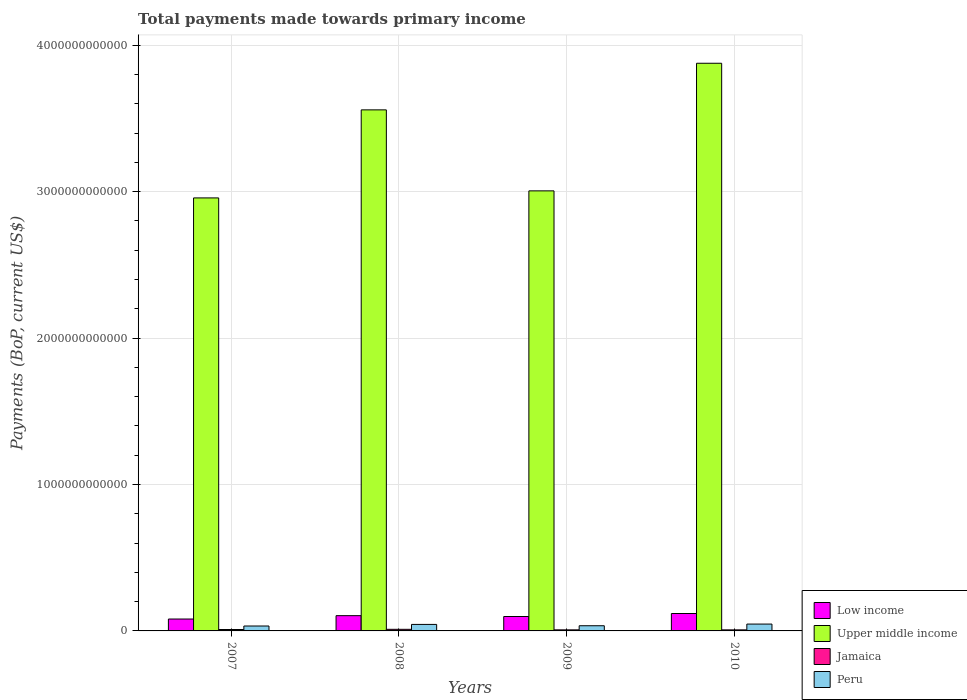How many different coloured bars are there?
Provide a succinct answer. 4. How many groups of bars are there?
Provide a succinct answer. 4. Are the number of bars on each tick of the X-axis equal?
Provide a short and direct response. Yes. How many bars are there on the 3rd tick from the left?
Provide a succinct answer. 4. What is the total payments made towards primary income in Jamaica in 2008?
Your answer should be very brief. 1.10e+1. Across all years, what is the maximum total payments made towards primary income in Low income?
Ensure brevity in your answer.  1.19e+11. Across all years, what is the minimum total payments made towards primary income in Upper middle income?
Keep it short and to the point. 2.96e+12. What is the total total payments made towards primary income in Upper middle income in the graph?
Your answer should be very brief. 1.34e+13. What is the difference between the total payments made towards primary income in Upper middle income in 2007 and that in 2009?
Give a very brief answer. -4.81e+1. What is the difference between the total payments made towards primary income in Upper middle income in 2008 and the total payments made towards primary income in Peru in 2010?
Make the answer very short. 3.51e+12. What is the average total payments made towards primary income in Upper middle income per year?
Provide a succinct answer. 3.35e+12. In the year 2007, what is the difference between the total payments made towards primary income in Peru and total payments made towards primary income in Jamaica?
Give a very brief answer. 2.39e+1. What is the ratio of the total payments made towards primary income in Peru in 2007 to that in 2010?
Ensure brevity in your answer.  0.72. Is the total payments made towards primary income in Jamaica in 2007 less than that in 2009?
Offer a terse response. No. What is the difference between the highest and the second highest total payments made towards primary income in Jamaica?
Provide a short and direct response. 1.30e+09. What is the difference between the highest and the lowest total payments made towards primary income in Peru?
Ensure brevity in your answer.  1.32e+1. In how many years, is the total payments made towards primary income in Upper middle income greater than the average total payments made towards primary income in Upper middle income taken over all years?
Your response must be concise. 2. Is it the case that in every year, the sum of the total payments made towards primary income in Low income and total payments made towards primary income in Jamaica is greater than the sum of total payments made towards primary income in Peru and total payments made towards primary income in Upper middle income?
Your answer should be compact. Yes. Is it the case that in every year, the sum of the total payments made towards primary income in Upper middle income and total payments made towards primary income in Peru is greater than the total payments made towards primary income in Low income?
Ensure brevity in your answer.  Yes. How many bars are there?
Offer a very short reply. 16. Are all the bars in the graph horizontal?
Give a very brief answer. No. How many years are there in the graph?
Your answer should be compact. 4. What is the difference between two consecutive major ticks on the Y-axis?
Your answer should be compact. 1.00e+12. Are the values on the major ticks of Y-axis written in scientific E-notation?
Keep it short and to the point. No. Does the graph contain any zero values?
Give a very brief answer. No. Does the graph contain grids?
Keep it short and to the point. Yes. How many legend labels are there?
Your answer should be compact. 4. How are the legend labels stacked?
Give a very brief answer. Vertical. What is the title of the graph?
Offer a very short reply. Total payments made towards primary income. What is the label or title of the Y-axis?
Offer a very short reply. Payments (BoP, current US$). What is the Payments (BoP, current US$) in Low income in 2007?
Give a very brief answer. 8.12e+1. What is the Payments (BoP, current US$) of Upper middle income in 2007?
Your answer should be compact. 2.96e+12. What is the Payments (BoP, current US$) in Jamaica in 2007?
Keep it short and to the point. 9.67e+09. What is the Payments (BoP, current US$) of Peru in 2007?
Provide a short and direct response. 3.36e+1. What is the Payments (BoP, current US$) of Low income in 2008?
Your answer should be very brief. 1.04e+11. What is the Payments (BoP, current US$) in Upper middle income in 2008?
Offer a very short reply. 3.56e+12. What is the Payments (BoP, current US$) in Jamaica in 2008?
Your answer should be compact. 1.10e+1. What is the Payments (BoP, current US$) of Peru in 2008?
Your answer should be very brief. 4.44e+1. What is the Payments (BoP, current US$) of Low income in 2009?
Provide a succinct answer. 9.84e+1. What is the Payments (BoP, current US$) in Upper middle income in 2009?
Give a very brief answer. 3.01e+12. What is the Payments (BoP, current US$) in Jamaica in 2009?
Offer a very short reply. 7.26e+09. What is the Payments (BoP, current US$) in Peru in 2009?
Offer a terse response. 3.54e+1. What is the Payments (BoP, current US$) of Low income in 2010?
Ensure brevity in your answer.  1.19e+11. What is the Payments (BoP, current US$) of Upper middle income in 2010?
Offer a terse response. 3.88e+12. What is the Payments (BoP, current US$) of Jamaica in 2010?
Provide a short and direct response. 7.19e+09. What is the Payments (BoP, current US$) of Peru in 2010?
Keep it short and to the point. 4.68e+1. Across all years, what is the maximum Payments (BoP, current US$) in Low income?
Make the answer very short. 1.19e+11. Across all years, what is the maximum Payments (BoP, current US$) of Upper middle income?
Give a very brief answer. 3.88e+12. Across all years, what is the maximum Payments (BoP, current US$) in Jamaica?
Your response must be concise. 1.10e+1. Across all years, what is the maximum Payments (BoP, current US$) in Peru?
Make the answer very short. 4.68e+1. Across all years, what is the minimum Payments (BoP, current US$) of Low income?
Offer a terse response. 8.12e+1. Across all years, what is the minimum Payments (BoP, current US$) in Upper middle income?
Your answer should be very brief. 2.96e+12. Across all years, what is the minimum Payments (BoP, current US$) in Jamaica?
Keep it short and to the point. 7.19e+09. Across all years, what is the minimum Payments (BoP, current US$) in Peru?
Your answer should be very brief. 3.36e+1. What is the total Payments (BoP, current US$) of Low income in the graph?
Provide a short and direct response. 4.03e+11. What is the total Payments (BoP, current US$) of Upper middle income in the graph?
Your answer should be very brief. 1.34e+13. What is the total Payments (BoP, current US$) in Jamaica in the graph?
Your answer should be very brief. 3.51e+1. What is the total Payments (BoP, current US$) of Peru in the graph?
Offer a very short reply. 1.60e+11. What is the difference between the Payments (BoP, current US$) of Low income in 2007 and that in 2008?
Keep it short and to the point. -2.30e+1. What is the difference between the Payments (BoP, current US$) in Upper middle income in 2007 and that in 2008?
Ensure brevity in your answer.  -6.01e+11. What is the difference between the Payments (BoP, current US$) in Jamaica in 2007 and that in 2008?
Make the answer very short. -1.30e+09. What is the difference between the Payments (BoP, current US$) in Peru in 2007 and that in 2008?
Ensure brevity in your answer.  -1.08e+1. What is the difference between the Payments (BoP, current US$) of Low income in 2007 and that in 2009?
Provide a succinct answer. -1.71e+1. What is the difference between the Payments (BoP, current US$) in Upper middle income in 2007 and that in 2009?
Make the answer very short. -4.81e+1. What is the difference between the Payments (BoP, current US$) in Jamaica in 2007 and that in 2009?
Your response must be concise. 2.41e+09. What is the difference between the Payments (BoP, current US$) of Peru in 2007 and that in 2009?
Your answer should be compact. -1.85e+09. What is the difference between the Payments (BoP, current US$) in Low income in 2007 and that in 2010?
Keep it short and to the point. -3.77e+1. What is the difference between the Payments (BoP, current US$) of Upper middle income in 2007 and that in 2010?
Give a very brief answer. -9.20e+11. What is the difference between the Payments (BoP, current US$) in Jamaica in 2007 and that in 2010?
Keep it short and to the point. 2.48e+09. What is the difference between the Payments (BoP, current US$) in Peru in 2007 and that in 2010?
Ensure brevity in your answer.  -1.32e+1. What is the difference between the Payments (BoP, current US$) in Low income in 2008 and that in 2009?
Keep it short and to the point. 5.85e+09. What is the difference between the Payments (BoP, current US$) of Upper middle income in 2008 and that in 2009?
Offer a terse response. 5.53e+11. What is the difference between the Payments (BoP, current US$) of Jamaica in 2008 and that in 2009?
Make the answer very short. 3.71e+09. What is the difference between the Payments (BoP, current US$) in Peru in 2008 and that in 2009?
Provide a succinct answer. 8.99e+09. What is the difference between the Payments (BoP, current US$) in Low income in 2008 and that in 2010?
Provide a succinct answer. -1.47e+1. What is the difference between the Payments (BoP, current US$) of Upper middle income in 2008 and that in 2010?
Provide a short and direct response. -3.18e+11. What is the difference between the Payments (BoP, current US$) of Jamaica in 2008 and that in 2010?
Provide a short and direct response. 3.78e+09. What is the difference between the Payments (BoP, current US$) in Peru in 2008 and that in 2010?
Give a very brief answer. -2.39e+09. What is the difference between the Payments (BoP, current US$) in Low income in 2009 and that in 2010?
Provide a short and direct response. -2.05e+1. What is the difference between the Payments (BoP, current US$) of Upper middle income in 2009 and that in 2010?
Make the answer very short. -8.71e+11. What is the difference between the Payments (BoP, current US$) of Jamaica in 2009 and that in 2010?
Give a very brief answer. 6.76e+07. What is the difference between the Payments (BoP, current US$) of Peru in 2009 and that in 2010?
Give a very brief answer. -1.14e+1. What is the difference between the Payments (BoP, current US$) of Low income in 2007 and the Payments (BoP, current US$) of Upper middle income in 2008?
Provide a short and direct response. -3.48e+12. What is the difference between the Payments (BoP, current US$) in Low income in 2007 and the Payments (BoP, current US$) in Jamaica in 2008?
Ensure brevity in your answer.  7.03e+1. What is the difference between the Payments (BoP, current US$) of Low income in 2007 and the Payments (BoP, current US$) of Peru in 2008?
Provide a succinct answer. 3.68e+1. What is the difference between the Payments (BoP, current US$) of Upper middle income in 2007 and the Payments (BoP, current US$) of Jamaica in 2008?
Offer a terse response. 2.95e+12. What is the difference between the Payments (BoP, current US$) of Upper middle income in 2007 and the Payments (BoP, current US$) of Peru in 2008?
Your answer should be compact. 2.91e+12. What is the difference between the Payments (BoP, current US$) of Jamaica in 2007 and the Payments (BoP, current US$) of Peru in 2008?
Your answer should be compact. -3.47e+1. What is the difference between the Payments (BoP, current US$) in Low income in 2007 and the Payments (BoP, current US$) in Upper middle income in 2009?
Your answer should be compact. -2.92e+12. What is the difference between the Payments (BoP, current US$) in Low income in 2007 and the Payments (BoP, current US$) in Jamaica in 2009?
Your answer should be compact. 7.40e+1. What is the difference between the Payments (BoP, current US$) of Low income in 2007 and the Payments (BoP, current US$) of Peru in 2009?
Provide a succinct answer. 4.58e+1. What is the difference between the Payments (BoP, current US$) in Upper middle income in 2007 and the Payments (BoP, current US$) in Jamaica in 2009?
Make the answer very short. 2.95e+12. What is the difference between the Payments (BoP, current US$) of Upper middle income in 2007 and the Payments (BoP, current US$) of Peru in 2009?
Offer a very short reply. 2.92e+12. What is the difference between the Payments (BoP, current US$) of Jamaica in 2007 and the Payments (BoP, current US$) of Peru in 2009?
Offer a terse response. -2.57e+1. What is the difference between the Payments (BoP, current US$) of Low income in 2007 and the Payments (BoP, current US$) of Upper middle income in 2010?
Make the answer very short. -3.80e+12. What is the difference between the Payments (BoP, current US$) of Low income in 2007 and the Payments (BoP, current US$) of Jamaica in 2010?
Give a very brief answer. 7.40e+1. What is the difference between the Payments (BoP, current US$) in Low income in 2007 and the Payments (BoP, current US$) in Peru in 2010?
Make the answer very short. 3.44e+1. What is the difference between the Payments (BoP, current US$) in Upper middle income in 2007 and the Payments (BoP, current US$) in Jamaica in 2010?
Your answer should be very brief. 2.95e+12. What is the difference between the Payments (BoP, current US$) of Upper middle income in 2007 and the Payments (BoP, current US$) of Peru in 2010?
Your response must be concise. 2.91e+12. What is the difference between the Payments (BoP, current US$) in Jamaica in 2007 and the Payments (BoP, current US$) in Peru in 2010?
Your response must be concise. -3.71e+1. What is the difference between the Payments (BoP, current US$) in Low income in 2008 and the Payments (BoP, current US$) in Upper middle income in 2009?
Provide a succinct answer. -2.90e+12. What is the difference between the Payments (BoP, current US$) of Low income in 2008 and the Payments (BoP, current US$) of Jamaica in 2009?
Provide a succinct answer. 9.70e+1. What is the difference between the Payments (BoP, current US$) in Low income in 2008 and the Payments (BoP, current US$) in Peru in 2009?
Offer a very short reply. 6.88e+1. What is the difference between the Payments (BoP, current US$) of Upper middle income in 2008 and the Payments (BoP, current US$) of Jamaica in 2009?
Make the answer very short. 3.55e+12. What is the difference between the Payments (BoP, current US$) of Upper middle income in 2008 and the Payments (BoP, current US$) of Peru in 2009?
Offer a very short reply. 3.52e+12. What is the difference between the Payments (BoP, current US$) of Jamaica in 2008 and the Payments (BoP, current US$) of Peru in 2009?
Your answer should be very brief. -2.44e+1. What is the difference between the Payments (BoP, current US$) in Low income in 2008 and the Payments (BoP, current US$) in Upper middle income in 2010?
Your answer should be very brief. -3.77e+12. What is the difference between the Payments (BoP, current US$) of Low income in 2008 and the Payments (BoP, current US$) of Jamaica in 2010?
Offer a terse response. 9.70e+1. What is the difference between the Payments (BoP, current US$) of Low income in 2008 and the Payments (BoP, current US$) of Peru in 2010?
Give a very brief answer. 5.74e+1. What is the difference between the Payments (BoP, current US$) of Upper middle income in 2008 and the Payments (BoP, current US$) of Jamaica in 2010?
Offer a terse response. 3.55e+12. What is the difference between the Payments (BoP, current US$) of Upper middle income in 2008 and the Payments (BoP, current US$) of Peru in 2010?
Provide a succinct answer. 3.51e+12. What is the difference between the Payments (BoP, current US$) in Jamaica in 2008 and the Payments (BoP, current US$) in Peru in 2010?
Make the answer very short. -3.58e+1. What is the difference between the Payments (BoP, current US$) of Low income in 2009 and the Payments (BoP, current US$) of Upper middle income in 2010?
Offer a terse response. -3.78e+12. What is the difference between the Payments (BoP, current US$) in Low income in 2009 and the Payments (BoP, current US$) in Jamaica in 2010?
Keep it short and to the point. 9.12e+1. What is the difference between the Payments (BoP, current US$) in Low income in 2009 and the Payments (BoP, current US$) in Peru in 2010?
Offer a very short reply. 5.16e+1. What is the difference between the Payments (BoP, current US$) in Upper middle income in 2009 and the Payments (BoP, current US$) in Jamaica in 2010?
Keep it short and to the point. 3.00e+12. What is the difference between the Payments (BoP, current US$) in Upper middle income in 2009 and the Payments (BoP, current US$) in Peru in 2010?
Your answer should be very brief. 2.96e+12. What is the difference between the Payments (BoP, current US$) in Jamaica in 2009 and the Payments (BoP, current US$) in Peru in 2010?
Keep it short and to the point. -3.95e+1. What is the average Payments (BoP, current US$) of Low income per year?
Your answer should be compact. 1.01e+11. What is the average Payments (BoP, current US$) of Upper middle income per year?
Make the answer very short. 3.35e+12. What is the average Payments (BoP, current US$) in Jamaica per year?
Provide a succinct answer. 8.77e+09. What is the average Payments (BoP, current US$) in Peru per year?
Offer a terse response. 4.00e+1. In the year 2007, what is the difference between the Payments (BoP, current US$) of Low income and Payments (BoP, current US$) of Upper middle income?
Keep it short and to the point. -2.88e+12. In the year 2007, what is the difference between the Payments (BoP, current US$) of Low income and Payments (BoP, current US$) of Jamaica?
Your answer should be very brief. 7.16e+1. In the year 2007, what is the difference between the Payments (BoP, current US$) of Low income and Payments (BoP, current US$) of Peru?
Give a very brief answer. 4.77e+1. In the year 2007, what is the difference between the Payments (BoP, current US$) of Upper middle income and Payments (BoP, current US$) of Jamaica?
Provide a succinct answer. 2.95e+12. In the year 2007, what is the difference between the Payments (BoP, current US$) of Upper middle income and Payments (BoP, current US$) of Peru?
Provide a succinct answer. 2.92e+12. In the year 2007, what is the difference between the Payments (BoP, current US$) in Jamaica and Payments (BoP, current US$) in Peru?
Your answer should be compact. -2.39e+1. In the year 2008, what is the difference between the Payments (BoP, current US$) of Low income and Payments (BoP, current US$) of Upper middle income?
Offer a very short reply. -3.45e+12. In the year 2008, what is the difference between the Payments (BoP, current US$) in Low income and Payments (BoP, current US$) in Jamaica?
Keep it short and to the point. 9.33e+1. In the year 2008, what is the difference between the Payments (BoP, current US$) in Low income and Payments (BoP, current US$) in Peru?
Your answer should be compact. 5.98e+1. In the year 2008, what is the difference between the Payments (BoP, current US$) in Upper middle income and Payments (BoP, current US$) in Jamaica?
Provide a succinct answer. 3.55e+12. In the year 2008, what is the difference between the Payments (BoP, current US$) in Upper middle income and Payments (BoP, current US$) in Peru?
Your response must be concise. 3.51e+12. In the year 2008, what is the difference between the Payments (BoP, current US$) in Jamaica and Payments (BoP, current US$) in Peru?
Provide a succinct answer. -3.34e+1. In the year 2009, what is the difference between the Payments (BoP, current US$) in Low income and Payments (BoP, current US$) in Upper middle income?
Provide a succinct answer. -2.91e+12. In the year 2009, what is the difference between the Payments (BoP, current US$) in Low income and Payments (BoP, current US$) in Jamaica?
Your answer should be very brief. 9.11e+1. In the year 2009, what is the difference between the Payments (BoP, current US$) in Low income and Payments (BoP, current US$) in Peru?
Give a very brief answer. 6.30e+1. In the year 2009, what is the difference between the Payments (BoP, current US$) of Upper middle income and Payments (BoP, current US$) of Jamaica?
Offer a terse response. 3.00e+12. In the year 2009, what is the difference between the Payments (BoP, current US$) in Upper middle income and Payments (BoP, current US$) in Peru?
Keep it short and to the point. 2.97e+12. In the year 2009, what is the difference between the Payments (BoP, current US$) in Jamaica and Payments (BoP, current US$) in Peru?
Keep it short and to the point. -2.82e+1. In the year 2010, what is the difference between the Payments (BoP, current US$) in Low income and Payments (BoP, current US$) in Upper middle income?
Ensure brevity in your answer.  -3.76e+12. In the year 2010, what is the difference between the Payments (BoP, current US$) in Low income and Payments (BoP, current US$) in Jamaica?
Ensure brevity in your answer.  1.12e+11. In the year 2010, what is the difference between the Payments (BoP, current US$) of Low income and Payments (BoP, current US$) of Peru?
Provide a succinct answer. 7.21e+1. In the year 2010, what is the difference between the Payments (BoP, current US$) in Upper middle income and Payments (BoP, current US$) in Jamaica?
Offer a very short reply. 3.87e+12. In the year 2010, what is the difference between the Payments (BoP, current US$) of Upper middle income and Payments (BoP, current US$) of Peru?
Your answer should be compact. 3.83e+12. In the year 2010, what is the difference between the Payments (BoP, current US$) in Jamaica and Payments (BoP, current US$) in Peru?
Make the answer very short. -3.96e+1. What is the ratio of the Payments (BoP, current US$) in Low income in 2007 to that in 2008?
Offer a terse response. 0.78. What is the ratio of the Payments (BoP, current US$) in Upper middle income in 2007 to that in 2008?
Make the answer very short. 0.83. What is the ratio of the Payments (BoP, current US$) of Jamaica in 2007 to that in 2008?
Your response must be concise. 0.88. What is the ratio of the Payments (BoP, current US$) in Peru in 2007 to that in 2008?
Offer a terse response. 0.76. What is the ratio of the Payments (BoP, current US$) in Low income in 2007 to that in 2009?
Give a very brief answer. 0.83. What is the ratio of the Payments (BoP, current US$) of Upper middle income in 2007 to that in 2009?
Your answer should be very brief. 0.98. What is the ratio of the Payments (BoP, current US$) of Jamaica in 2007 to that in 2009?
Your response must be concise. 1.33. What is the ratio of the Payments (BoP, current US$) in Peru in 2007 to that in 2009?
Your answer should be very brief. 0.95. What is the ratio of the Payments (BoP, current US$) in Low income in 2007 to that in 2010?
Make the answer very short. 0.68. What is the ratio of the Payments (BoP, current US$) in Upper middle income in 2007 to that in 2010?
Your answer should be compact. 0.76. What is the ratio of the Payments (BoP, current US$) in Jamaica in 2007 to that in 2010?
Your response must be concise. 1.34. What is the ratio of the Payments (BoP, current US$) of Peru in 2007 to that in 2010?
Your response must be concise. 0.72. What is the ratio of the Payments (BoP, current US$) in Low income in 2008 to that in 2009?
Keep it short and to the point. 1.06. What is the ratio of the Payments (BoP, current US$) in Upper middle income in 2008 to that in 2009?
Provide a short and direct response. 1.18. What is the ratio of the Payments (BoP, current US$) of Jamaica in 2008 to that in 2009?
Keep it short and to the point. 1.51. What is the ratio of the Payments (BoP, current US$) in Peru in 2008 to that in 2009?
Your answer should be compact. 1.25. What is the ratio of the Payments (BoP, current US$) of Low income in 2008 to that in 2010?
Your answer should be compact. 0.88. What is the ratio of the Payments (BoP, current US$) of Upper middle income in 2008 to that in 2010?
Your answer should be very brief. 0.92. What is the ratio of the Payments (BoP, current US$) in Jamaica in 2008 to that in 2010?
Offer a very short reply. 1.53. What is the ratio of the Payments (BoP, current US$) in Peru in 2008 to that in 2010?
Ensure brevity in your answer.  0.95. What is the ratio of the Payments (BoP, current US$) in Low income in 2009 to that in 2010?
Offer a very short reply. 0.83. What is the ratio of the Payments (BoP, current US$) in Upper middle income in 2009 to that in 2010?
Your answer should be compact. 0.78. What is the ratio of the Payments (BoP, current US$) of Jamaica in 2009 to that in 2010?
Offer a very short reply. 1.01. What is the ratio of the Payments (BoP, current US$) of Peru in 2009 to that in 2010?
Your response must be concise. 0.76. What is the difference between the highest and the second highest Payments (BoP, current US$) in Low income?
Your answer should be very brief. 1.47e+1. What is the difference between the highest and the second highest Payments (BoP, current US$) of Upper middle income?
Your response must be concise. 3.18e+11. What is the difference between the highest and the second highest Payments (BoP, current US$) in Jamaica?
Offer a terse response. 1.30e+09. What is the difference between the highest and the second highest Payments (BoP, current US$) of Peru?
Your response must be concise. 2.39e+09. What is the difference between the highest and the lowest Payments (BoP, current US$) of Low income?
Your answer should be compact. 3.77e+1. What is the difference between the highest and the lowest Payments (BoP, current US$) in Upper middle income?
Provide a succinct answer. 9.20e+11. What is the difference between the highest and the lowest Payments (BoP, current US$) in Jamaica?
Provide a succinct answer. 3.78e+09. What is the difference between the highest and the lowest Payments (BoP, current US$) in Peru?
Offer a terse response. 1.32e+1. 